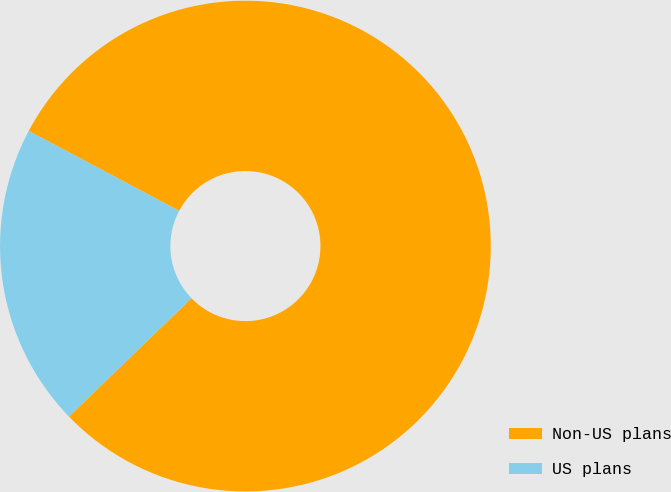Convert chart. <chart><loc_0><loc_0><loc_500><loc_500><pie_chart><fcel>Non-US plans<fcel>US plans<nl><fcel>80.0%<fcel>20.0%<nl></chart> 